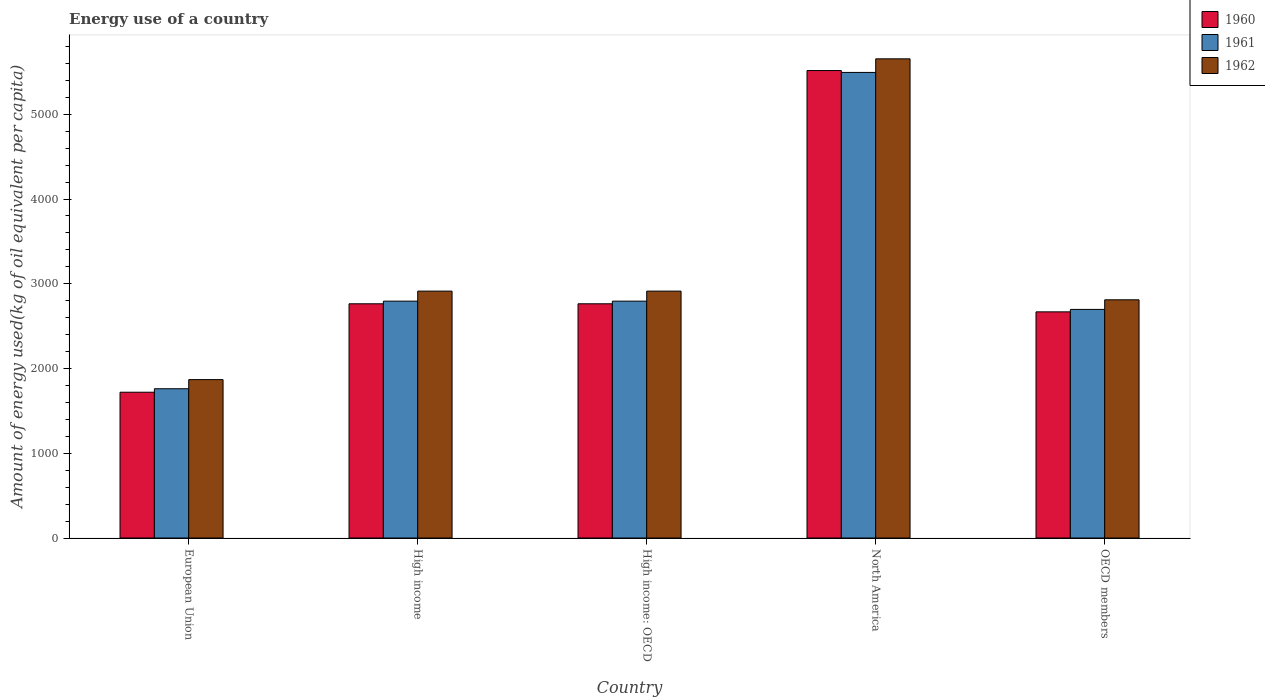How many different coloured bars are there?
Provide a succinct answer. 3. How many groups of bars are there?
Ensure brevity in your answer.  5. How many bars are there on the 5th tick from the left?
Provide a succinct answer. 3. What is the label of the 3rd group of bars from the left?
Provide a short and direct response. High income: OECD. In how many cases, is the number of bars for a given country not equal to the number of legend labels?
Ensure brevity in your answer.  0. What is the amount of energy used in in 1961 in North America?
Offer a terse response. 5494.09. Across all countries, what is the maximum amount of energy used in in 1960?
Your response must be concise. 5516.36. Across all countries, what is the minimum amount of energy used in in 1962?
Your answer should be very brief. 1869.04. What is the total amount of energy used in in 1961 in the graph?
Ensure brevity in your answer.  1.55e+04. What is the difference between the amount of energy used in in 1961 in High income: OECD and that in North America?
Give a very brief answer. -2698.95. What is the difference between the amount of energy used in in 1960 in OECD members and the amount of energy used in in 1962 in European Union?
Give a very brief answer. 799.66. What is the average amount of energy used in in 1961 per country?
Your answer should be very brief. 3108.66. What is the difference between the amount of energy used in of/in 1962 and amount of energy used in of/in 1960 in North America?
Ensure brevity in your answer.  138.19. In how many countries, is the amount of energy used in in 1962 greater than 1400 kg?
Offer a terse response. 5. What is the ratio of the amount of energy used in in 1961 in European Union to that in High income: OECD?
Make the answer very short. 0.63. Is the amount of energy used in in 1962 in European Union less than that in High income: OECD?
Provide a succinct answer. Yes. What is the difference between the highest and the second highest amount of energy used in in 1961?
Your answer should be compact. -2698.95. What is the difference between the highest and the lowest amount of energy used in in 1960?
Offer a terse response. 3796.04. Is it the case that in every country, the sum of the amount of energy used in in 1961 and amount of energy used in in 1960 is greater than the amount of energy used in in 1962?
Provide a short and direct response. Yes. Are all the bars in the graph horizontal?
Your answer should be compact. No. Does the graph contain any zero values?
Provide a succinct answer. No. Does the graph contain grids?
Provide a succinct answer. No. Where does the legend appear in the graph?
Your response must be concise. Top right. How many legend labels are there?
Your response must be concise. 3. How are the legend labels stacked?
Ensure brevity in your answer.  Vertical. What is the title of the graph?
Make the answer very short. Energy use of a country. Does "1980" appear as one of the legend labels in the graph?
Make the answer very short. No. What is the label or title of the Y-axis?
Offer a very short reply. Amount of energy used(kg of oil equivalent per capita). What is the Amount of energy used(kg of oil equivalent per capita) of 1960 in European Union?
Give a very brief answer. 1720.32. What is the Amount of energy used(kg of oil equivalent per capita) of 1961 in European Union?
Provide a short and direct response. 1761.41. What is the Amount of energy used(kg of oil equivalent per capita) in 1962 in European Union?
Offer a very short reply. 1869.04. What is the Amount of energy used(kg of oil equivalent per capita) in 1960 in High income?
Your answer should be very brief. 2763.96. What is the Amount of energy used(kg of oil equivalent per capita) in 1961 in High income?
Your response must be concise. 2795.14. What is the Amount of energy used(kg of oil equivalent per capita) in 1962 in High income?
Offer a very short reply. 2913.43. What is the Amount of energy used(kg of oil equivalent per capita) in 1960 in High income: OECD?
Your answer should be compact. 2763.96. What is the Amount of energy used(kg of oil equivalent per capita) of 1961 in High income: OECD?
Ensure brevity in your answer.  2795.14. What is the Amount of energy used(kg of oil equivalent per capita) of 1962 in High income: OECD?
Make the answer very short. 2913.43. What is the Amount of energy used(kg of oil equivalent per capita) of 1960 in North America?
Provide a succinct answer. 5516.36. What is the Amount of energy used(kg of oil equivalent per capita) of 1961 in North America?
Provide a short and direct response. 5494.09. What is the Amount of energy used(kg of oil equivalent per capita) of 1962 in North America?
Give a very brief answer. 5654.54. What is the Amount of energy used(kg of oil equivalent per capita) in 1960 in OECD members?
Offer a very short reply. 2668.69. What is the Amount of energy used(kg of oil equivalent per capita) of 1961 in OECD members?
Make the answer very short. 2697.51. What is the Amount of energy used(kg of oil equivalent per capita) of 1962 in OECD members?
Keep it short and to the point. 2810.85. Across all countries, what is the maximum Amount of energy used(kg of oil equivalent per capita) of 1960?
Offer a terse response. 5516.36. Across all countries, what is the maximum Amount of energy used(kg of oil equivalent per capita) of 1961?
Give a very brief answer. 5494.09. Across all countries, what is the maximum Amount of energy used(kg of oil equivalent per capita) in 1962?
Ensure brevity in your answer.  5654.54. Across all countries, what is the minimum Amount of energy used(kg of oil equivalent per capita) in 1960?
Ensure brevity in your answer.  1720.32. Across all countries, what is the minimum Amount of energy used(kg of oil equivalent per capita) in 1961?
Make the answer very short. 1761.41. Across all countries, what is the minimum Amount of energy used(kg of oil equivalent per capita) of 1962?
Provide a short and direct response. 1869.04. What is the total Amount of energy used(kg of oil equivalent per capita) in 1960 in the graph?
Make the answer very short. 1.54e+04. What is the total Amount of energy used(kg of oil equivalent per capita) in 1961 in the graph?
Give a very brief answer. 1.55e+04. What is the total Amount of energy used(kg of oil equivalent per capita) in 1962 in the graph?
Offer a terse response. 1.62e+04. What is the difference between the Amount of energy used(kg of oil equivalent per capita) of 1960 in European Union and that in High income?
Your answer should be compact. -1043.64. What is the difference between the Amount of energy used(kg of oil equivalent per capita) in 1961 in European Union and that in High income?
Your answer should be very brief. -1033.73. What is the difference between the Amount of energy used(kg of oil equivalent per capita) of 1962 in European Union and that in High income?
Make the answer very short. -1044.39. What is the difference between the Amount of energy used(kg of oil equivalent per capita) of 1960 in European Union and that in High income: OECD?
Provide a short and direct response. -1043.64. What is the difference between the Amount of energy used(kg of oil equivalent per capita) of 1961 in European Union and that in High income: OECD?
Offer a very short reply. -1033.73. What is the difference between the Amount of energy used(kg of oil equivalent per capita) in 1962 in European Union and that in High income: OECD?
Make the answer very short. -1044.39. What is the difference between the Amount of energy used(kg of oil equivalent per capita) of 1960 in European Union and that in North America?
Your response must be concise. -3796.04. What is the difference between the Amount of energy used(kg of oil equivalent per capita) of 1961 in European Union and that in North America?
Keep it short and to the point. -3732.68. What is the difference between the Amount of energy used(kg of oil equivalent per capita) in 1962 in European Union and that in North America?
Your response must be concise. -3785.51. What is the difference between the Amount of energy used(kg of oil equivalent per capita) of 1960 in European Union and that in OECD members?
Provide a short and direct response. -948.38. What is the difference between the Amount of energy used(kg of oil equivalent per capita) in 1961 in European Union and that in OECD members?
Ensure brevity in your answer.  -936.11. What is the difference between the Amount of energy used(kg of oil equivalent per capita) of 1962 in European Union and that in OECD members?
Your response must be concise. -941.81. What is the difference between the Amount of energy used(kg of oil equivalent per capita) of 1960 in High income and that in High income: OECD?
Your answer should be compact. 0. What is the difference between the Amount of energy used(kg of oil equivalent per capita) in 1961 in High income and that in High income: OECD?
Your response must be concise. 0. What is the difference between the Amount of energy used(kg of oil equivalent per capita) of 1962 in High income and that in High income: OECD?
Offer a very short reply. 0. What is the difference between the Amount of energy used(kg of oil equivalent per capita) in 1960 in High income and that in North America?
Provide a short and direct response. -2752.4. What is the difference between the Amount of energy used(kg of oil equivalent per capita) in 1961 in High income and that in North America?
Keep it short and to the point. -2698.95. What is the difference between the Amount of energy used(kg of oil equivalent per capita) of 1962 in High income and that in North America?
Ensure brevity in your answer.  -2741.12. What is the difference between the Amount of energy used(kg of oil equivalent per capita) in 1960 in High income and that in OECD members?
Offer a terse response. 95.27. What is the difference between the Amount of energy used(kg of oil equivalent per capita) in 1961 in High income and that in OECD members?
Ensure brevity in your answer.  97.63. What is the difference between the Amount of energy used(kg of oil equivalent per capita) in 1962 in High income and that in OECD members?
Provide a short and direct response. 102.57. What is the difference between the Amount of energy used(kg of oil equivalent per capita) in 1960 in High income: OECD and that in North America?
Your answer should be compact. -2752.4. What is the difference between the Amount of energy used(kg of oil equivalent per capita) of 1961 in High income: OECD and that in North America?
Offer a very short reply. -2698.95. What is the difference between the Amount of energy used(kg of oil equivalent per capita) in 1962 in High income: OECD and that in North America?
Your response must be concise. -2741.12. What is the difference between the Amount of energy used(kg of oil equivalent per capita) of 1960 in High income: OECD and that in OECD members?
Ensure brevity in your answer.  95.27. What is the difference between the Amount of energy used(kg of oil equivalent per capita) in 1961 in High income: OECD and that in OECD members?
Give a very brief answer. 97.63. What is the difference between the Amount of energy used(kg of oil equivalent per capita) of 1962 in High income: OECD and that in OECD members?
Your answer should be very brief. 102.57. What is the difference between the Amount of energy used(kg of oil equivalent per capita) in 1960 in North America and that in OECD members?
Make the answer very short. 2847.66. What is the difference between the Amount of energy used(kg of oil equivalent per capita) in 1961 in North America and that in OECD members?
Keep it short and to the point. 2796.57. What is the difference between the Amount of energy used(kg of oil equivalent per capita) in 1962 in North America and that in OECD members?
Your response must be concise. 2843.69. What is the difference between the Amount of energy used(kg of oil equivalent per capita) of 1960 in European Union and the Amount of energy used(kg of oil equivalent per capita) of 1961 in High income?
Keep it short and to the point. -1074.82. What is the difference between the Amount of energy used(kg of oil equivalent per capita) of 1960 in European Union and the Amount of energy used(kg of oil equivalent per capita) of 1962 in High income?
Your answer should be very brief. -1193.11. What is the difference between the Amount of energy used(kg of oil equivalent per capita) in 1961 in European Union and the Amount of energy used(kg of oil equivalent per capita) in 1962 in High income?
Your answer should be compact. -1152.02. What is the difference between the Amount of energy used(kg of oil equivalent per capita) of 1960 in European Union and the Amount of energy used(kg of oil equivalent per capita) of 1961 in High income: OECD?
Offer a terse response. -1074.82. What is the difference between the Amount of energy used(kg of oil equivalent per capita) in 1960 in European Union and the Amount of energy used(kg of oil equivalent per capita) in 1962 in High income: OECD?
Keep it short and to the point. -1193.11. What is the difference between the Amount of energy used(kg of oil equivalent per capita) of 1961 in European Union and the Amount of energy used(kg of oil equivalent per capita) of 1962 in High income: OECD?
Your response must be concise. -1152.02. What is the difference between the Amount of energy used(kg of oil equivalent per capita) in 1960 in European Union and the Amount of energy used(kg of oil equivalent per capita) in 1961 in North America?
Offer a very short reply. -3773.77. What is the difference between the Amount of energy used(kg of oil equivalent per capita) in 1960 in European Union and the Amount of energy used(kg of oil equivalent per capita) in 1962 in North America?
Your response must be concise. -3934.23. What is the difference between the Amount of energy used(kg of oil equivalent per capita) of 1961 in European Union and the Amount of energy used(kg of oil equivalent per capita) of 1962 in North America?
Provide a succinct answer. -3893.14. What is the difference between the Amount of energy used(kg of oil equivalent per capita) in 1960 in European Union and the Amount of energy used(kg of oil equivalent per capita) in 1961 in OECD members?
Offer a very short reply. -977.2. What is the difference between the Amount of energy used(kg of oil equivalent per capita) of 1960 in European Union and the Amount of energy used(kg of oil equivalent per capita) of 1962 in OECD members?
Make the answer very short. -1090.54. What is the difference between the Amount of energy used(kg of oil equivalent per capita) of 1961 in European Union and the Amount of energy used(kg of oil equivalent per capita) of 1962 in OECD members?
Your answer should be very brief. -1049.45. What is the difference between the Amount of energy used(kg of oil equivalent per capita) of 1960 in High income and the Amount of energy used(kg of oil equivalent per capita) of 1961 in High income: OECD?
Make the answer very short. -31.18. What is the difference between the Amount of energy used(kg of oil equivalent per capita) in 1960 in High income and the Amount of energy used(kg of oil equivalent per capita) in 1962 in High income: OECD?
Your answer should be very brief. -149.47. What is the difference between the Amount of energy used(kg of oil equivalent per capita) of 1961 in High income and the Amount of energy used(kg of oil equivalent per capita) of 1962 in High income: OECD?
Provide a short and direct response. -118.28. What is the difference between the Amount of energy used(kg of oil equivalent per capita) of 1960 in High income and the Amount of energy used(kg of oil equivalent per capita) of 1961 in North America?
Keep it short and to the point. -2730.13. What is the difference between the Amount of energy used(kg of oil equivalent per capita) of 1960 in High income and the Amount of energy used(kg of oil equivalent per capita) of 1962 in North America?
Give a very brief answer. -2890.59. What is the difference between the Amount of energy used(kg of oil equivalent per capita) of 1961 in High income and the Amount of energy used(kg of oil equivalent per capita) of 1962 in North America?
Your response must be concise. -2859.4. What is the difference between the Amount of energy used(kg of oil equivalent per capita) of 1960 in High income and the Amount of energy used(kg of oil equivalent per capita) of 1961 in OECD members?
Your response must be concise. 66.45. What is the difference between the Amount of energy used(kg of oil equivalent per capita) of 1960 in High income and the Amount of energy used(kg of oil equivalent per capita) of 1962 in OECD members?
Your answer should be compact. -46.89. What is the difference between the Amount of energy used(kg of oil equivalent per capita) in 1961 in High income and the Amount of energy used(kg of oil equivalent per capita) in 1962 in OECD members?
Give a very brief answer. -15.71. What is the difference between the Amount of energy used(kg of oil equivalent per capita) in 1960 in High income: OECD and the Amount of energy used(kg of oil equivalent per capita) in 1961 in North America?
Give a very brief answer. -2730.13. What is the difference between the Amount of energy used(kg of oil equivalent per capita) of 1960 in High income: OECD and the Amount of energy used(kg of oil equivalent per capita) of 1962 in North America?
Ensure brevity in your answer.  -2890.59. What is the difference between the Amount of energy used(kg of oil equivalent per capita) of 1961 in High income: OECD and the Amount of energy used(kg of oil equivalent per capita) of 1962 in North America?
Your answer should be very brief. -2859.4. What is the difference between the Amount of energy used(kg of oil equivalent per capita) in 1960 in High income: OECD and the Amount of energy used(kg of oil equivalent per capita) in 1961 in OECD members?
Your response must be concise. 66.45. What is the difference between the Amount of energy used(kg of oil equivalent per capita) of 1960 in High income: OECD and the Amount of energy used(kg of oil equivalent per capita) of 1962 in OECD members?
Offer a terse response. -46.89. What is the difference between the Amount of energy used(kg of oil equivalent per capita) of 1961 in High income: OECD and the Amount of energy used(kg of oil equivalent per capita) of 1962 in OECD members?
Your response must be concise. -15.71. What is the difference between the Amount of energy used(kg of oil equivalent per capita) in 1960 in North America and the Amount of energy used(kg of oil equivalent per capita) in 1961 in OECD members?
Provide a short and direct response. 2818.84. What is the difference between the Amount of energy used(kg of oil equivalent per capita) of 1960 in North America and the Amount of energy used(kg of oil equivalent per capita) of 1962 in OECD members?
Provide a short and direct response. 2705.5. What is the difference between the Amount of energy used(kg of oil equivalent per capita) in 1961 in North America and the Amount of energy used(kg of oil equivalent per capita) in 1962 in OECD members?
Give a very brief answer. 2683.23. What is the average Amount of energy used(kg of oil equivalent per capita) in 1960 per country?
Make the answer very short. 3086.66. What is the average Amount of energy used(kg of oil equivalent per capita) of 1961 per country?
Keep it short and to the point. 3108.66. What is the average Amount of energy used(kg of oil equivalent per capita) of 1962 per country?
Give a very brief answer. 3232.26. What is the difference between the Amount of energy used(kg of oil equivalent per capita) in 1960 and Amount of energy used(kg of oil equivalent per capita) in 1961 in European Union?
Your answer should be very brief. -41.09. What is the difference between the Amount of energy used(kg of oil equivalent per capita) in 1960 and Amount of energy used(kg of oil equivalent per capita) in 1962 in European Union?
Make the answer very short. -148.72. What is the difference between the Amount of energy used(kg of oil equivalent per capita) of 1961 and Amount of energy used(kg of oil equivalent per capita) of 1962 in European Union?
Offer a very short reply. -107.63. What is the difference between the Amount of energy used(kg of oil equivalent per capita) in 1960 and Amount of energy used(kg of oil equivalent per capita) in 1961 in High income?
Give a very brief answer. -31.18. What is the difference between the Amount of energy used(kg of oil equivalent per capita) of 1960 and Amount of energy used(kg of oil equivalent per capita) of 1962 in High income?
Provide a short and direct response. -149.47. What is the difference between the Amount of energy used(kg of oil equivalent per capita) in 1961 and Amount of energy used(kg of oil equivalent per capita) in 1962 in High income?
Give a very brief answer. -118.28. What is the difference between the Amount of energy used(kg of oil equivalent per capita) of 1960 and Amount of energy used(kg of oil equivalent per capita) of 1961 in High income: OECD?
Make the answer very short. -31.18. What is the difference between the Amount of energy used(kg of oil equivalent per capita) of 1960 and Amount of energy used(kg of oil equivalent per capita) of 1962 in High income: OECD?
Provide a short and direct response. -149.47. What is the difference between the Amount of energy used(kg of oil equivalent per capita) of 1961 and Amount of energy used(kg of oil equivalent per capita) of 1962 in High income: OECD?
Your response must be concise. -118.28. What is the difference between the Amount of energy used(kg of oil equivalent per capita) in 1960 and Amount of energy used(kg of oil equivalent per capita) in 1961 in North America?
Ensure brevity in your answer.  22.27. What is the difference between the Amount of energy used(kg of oil equivalent per capita) of 1960 and Amount of energy used(kg of oil equivalent per capita) of 1962 in North America?
Offer a terse response. -138.19. What is the difference between the Amount of energy used(kg of oil equivalent per capita) of 1961 and Amount of energy used(kg of oil equivalent per capita) of 1962 in North America?
Provide a short and direct response. -160.46. What is the difference between the Amount of energy used(kg of oil equivalent per capita) in 1960 and Amount of energy used(kg of oil equivalent per capita) in 1961 in OECD members?
Offer a terse response. -28.82. What is the difference between the Amount of energy used(kg of oil equivalent per capita) of 1960 and Amount of energy used(kg of oil equivalent per capita) of 1962 in OECD members?
Your response must be concise. -142.16. What is the difference between the Amount of energy used(kg of oil equivalent per capita) in 1961 and Amount of energy used(kg of oil equivalent per capita) in 1962 in OECD members?
Your answer should be very brief. -113.34. What is the ratio of the Amount of energy used(kg of oil equivalent per capita) of 1960 in European Union to that in High income?
Offer a terse response. 0.62. What is the ratio of the Amount of energy used(kg of oil equivalent per capita) of 1961 in European Union to that in High income?
Provide a succinct answer. 0.63. What is the ratio of the Amount of energy used(kg of oil equivalent per capita) of 1962 in European Union to that in High income?
Ensure brevity in your answer.  0.64. What is the ratio of the Amount of energy used(kg of oil equivalent per capita) of 1960 in European Union to that in High income: OECD?
Provide a succinct answer. 0.62. What is the ratio of the Amount of energy used(kg of oil equivalent per capita) in 1961 in European Union to that in High income: OECD?
Offer a very short reply. 0.63. What is the ratio of the Amount of energy used(kg of oil equivalent per capita) of 1962 in European Union to that in High income: OECD?
Your response must be concise. 0.64. What is the ratio of the Amount of energy used(kg of oil equivalent per capita) in 1960 in European Union to that in North America?
Offer a very short reply. 0.31. What is the ratio of the Amount of energy used(kg of oil equivalent per capita) of 1961 in European Union to that in North America?
Make the answer very short. 0.32. What is the ratio of the Amount of energy used(kg of oil equivalent per capita) of 1962 in European Union to that in North America?
Offer a very short reply. 0.33. What is the ratio of the Amount of energy used(kg of oil equivalent per capita) in 1960 in European Union to that in OECD members?
Offer a terse response. 0.64. What is the ratio of the Amount of energy used(kg of oil equivalent per capita) in 1961 in European Union to that in OECD members?
Your response must be concise. 0.65. What is the ratio of the Amount of energy used(kg of oil equivalent per capita) in 1962 in European Union to that in OECD members?
Your answer should be very brief. 0.66. What is the ratio of the Amount of energy used(kg of oil equivalent per capita) in 1962 in High income to that in High income: OECD?
Give a very brief answer. 1. What is the ratio of the Amount of energy used(kg of oil equivalent per capita) in 1960 in High income to that in North America?
Your answer should be compact. 0.5. What is the ratio of the Amount of energy used(kg of oil equivalent per capita) of 1961 in High income to that in North America?
Your answer should be very brief. 0.51. What is the ratio of the Amount of energy used(kg of oil equivalent per capita) in 1962 in High income to that in North America?
Keep it short and to the point. 0.52. What is the ratio of the Amount of energy used(kg of oil equivalent per capita) of 1960 in High income to that in OECD members?
Your answer should be compact. 1.04. What is the ratio of the Amount of energy used(kg of oil equivalent per capita) in 1961 in High income to that in OECD members?
Make the answer very short. 1.04. What is the ratio of the Amount of energy used(kg of oil equivalent per capita) in 1962 in High income to that in OECD members?
Your answer should be very brief. 1.04. What is the ratio of the Amount of energy used(kg of oil equivalent per capita) of 1960 in High income: OECD to that in North America?
Your response must be concise. 0.5. What is the ratio of the Amount of energy used(kg of oil equivalent per capita) of 1961 in High income: OECD to that in North America?
Your answer should be very brief. 0.51. What is the ratio of the Amount of energy used(kg of oil equivalent per capita) of 1962 in High income: OECD to that in North America?
Your answer should be compact. 0.52. What is the ratio of the Amount of energy used(kg of oil equivalent per capita) in 1960 in High income: OECD to that in OECD members?
Your response must be concise. 1.04. What is the ratio of the Amount of energy used(kg of oil equivalent per capita) in 1961 in High income: OECD to that in OECD members?
Offer a terse response. 1.04. What is the ratio of the Amount of energy used(kg of oil equivalent per capita) in 1962 in High income: OECD to that in OECD members?
Your answer should be very brief. 1.04. What is the ratio of the Amount of energy used(kg of oil equivalent per capita) in 1960 in North America to that in OECD members?
Provide a succinct answer. 2.07. What is the ratio of the Amount of energy used(kg of oil equivalent per capita) in 1961 in North America to that in OECD members?
Offer a terse response. 2.04. What is the ratio of the Amount of energy used(kg of oil equivalent per capita) in 1962 in North America to that in OECD members?
Your answer should be compact. 2.01. What is the difference between the highest and the second highest Amount of energy used(kg of oil equivalent per capita) of 1960?
Give a very brief answer. 2752.4. What is the difference between the highest and the second highest Amount of energy used(kg of oil equivalent per capita) of 1961?
Offer a very short reply. 2698.95. What is the difference between the highest and the second highest Amount of energy used(kg of oil equivalent per capita) in 1962?
Your answer should be compact. 2741.12. What is the difference between the highest and the lowest Amount of energy used(kg of oil equivalent per capita) in 1960?
Give a very brief answer. 3796.04. What is the difference between the highest and the lowest Amount of energy used(kg of oil equivalent per capita) of 1961?
Keep it short and to the point. 3732.68. What is the difference between the highest and the lowest Amount of energy used(kg of oil equivalent per capita) of 1962?
Offer a terse response. 3785.51. 